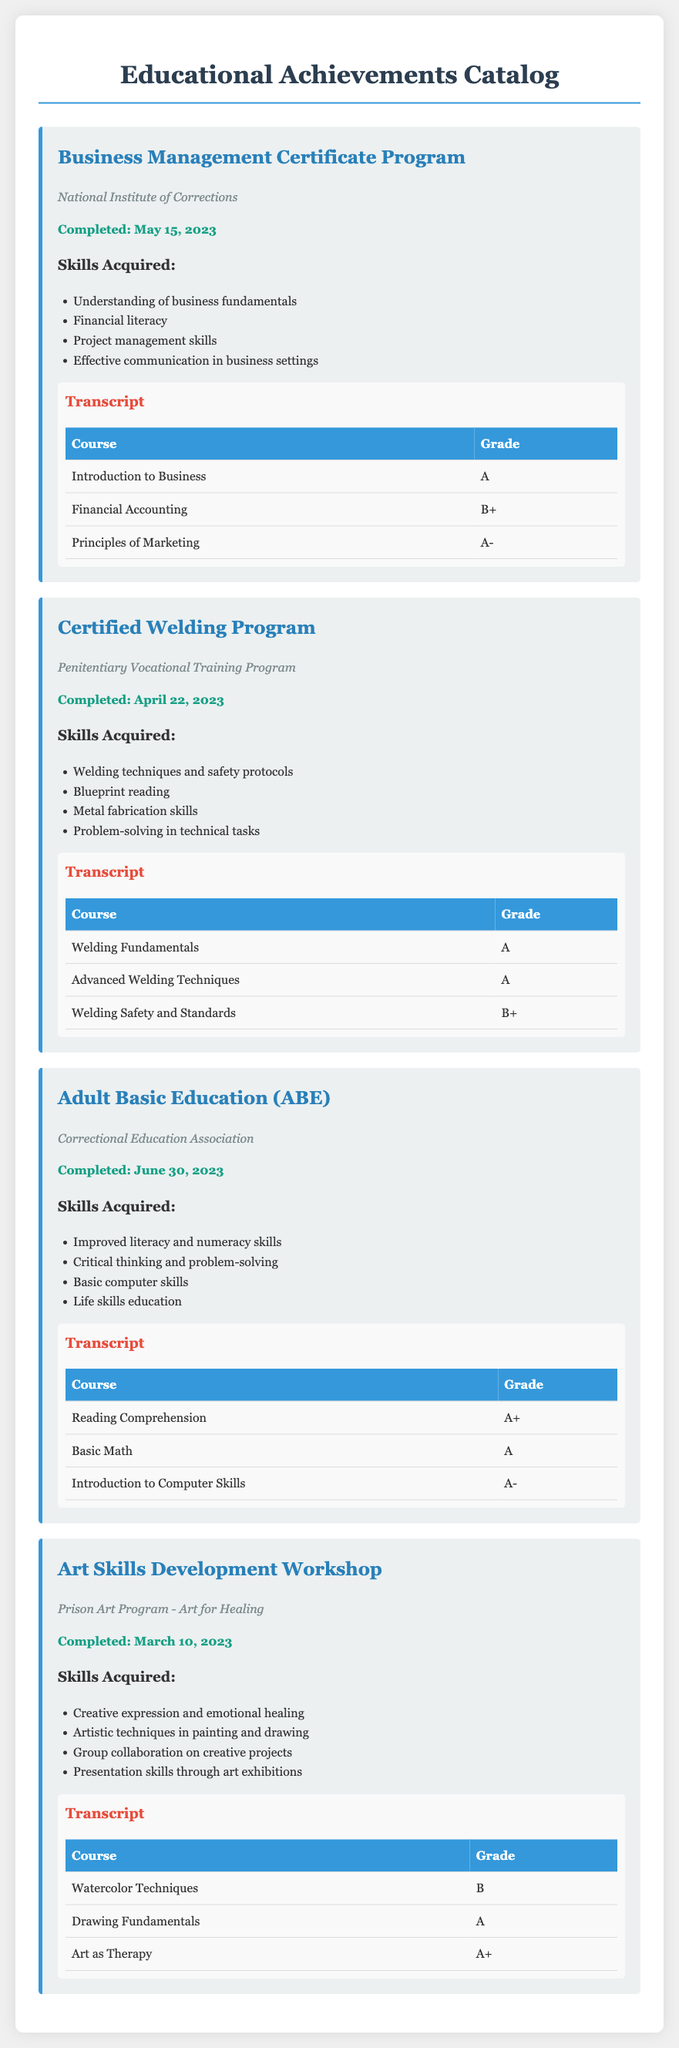What is the title of the first program listed? The title of the first program is found at the top of the first program section in the document.
Answer: Business Management Certificate Program Who is the institution for the Certified Welding Program? The institution for the Certified Welding Program is mentioned directly under the program title.
Answer: Penitentiary Vocational Training Program What is the completion date for the Adult Basic Education program? The completion date is provided in the document under the respective program section.
Answer: June 30, 2023 Which skill acquired is listed for the Art Skills Development Workshop? Skills acquired are listed in the program section, and any can be referenced.
Answer: Creative expression and emotional healing What grade did the course "Financial Accounting" receive? The grade for "Financial Accounting" is found in the transcript table under the relevant program.
Answer: B+ How many courses are listed in the transcript for the Certified Welding Program? The number of courses can be counted from the transcript table in that program section.
Answer: 3 What type of program is the Adult Basic Education classified as? The classification of the Adult Basic Education program is given by the institution that runs it.
Answer: Correctional Education Association Which course received the highest grade in the Business Management Certificate Program? The course grades are listed in the transcript table where the highest grade can be identified.
Answer: Introduction to Business What are the skills acquired in the Adult Basic Education program? Skills acquired for the Adult Basic Education program are listed in the respective program section.
Answer: Improved literacy and numeracy skills 